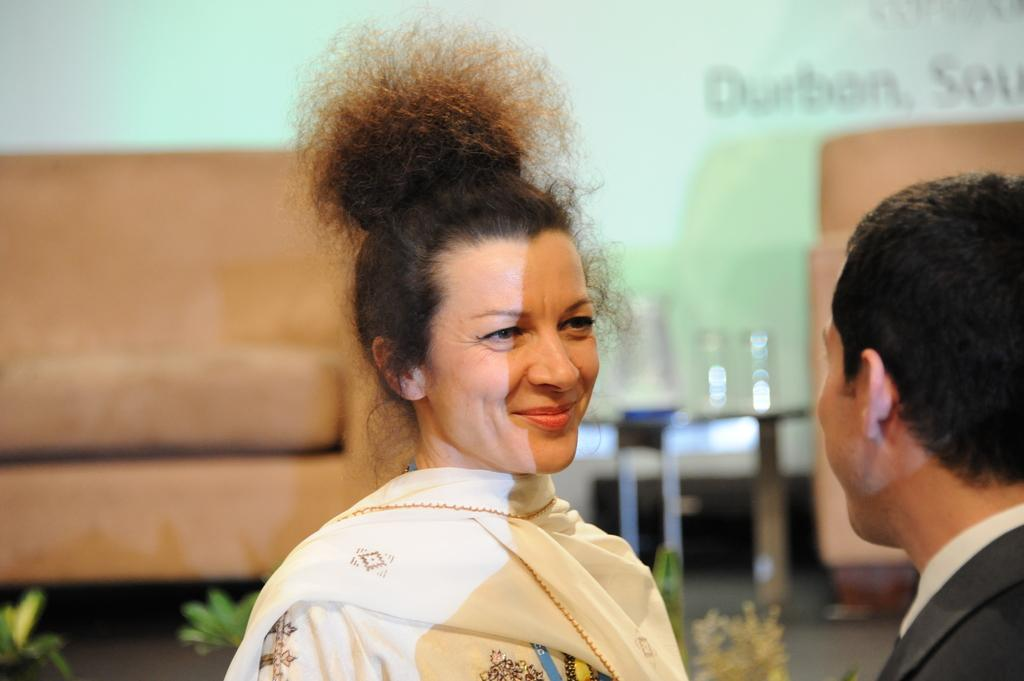How many people are in the image? There are two people in the image. Can you describe one of the people in the image? One of the people is a woman who is smiling. What can be seen in the background of the image? The background of the image is blurry, and there are sofas and plants visible. What color is associated with the background of the image? The color green is associated with the background of the image. What type of soup is being prepared by the woman in the image? There is no soup or any indication of food preparation in the image. 